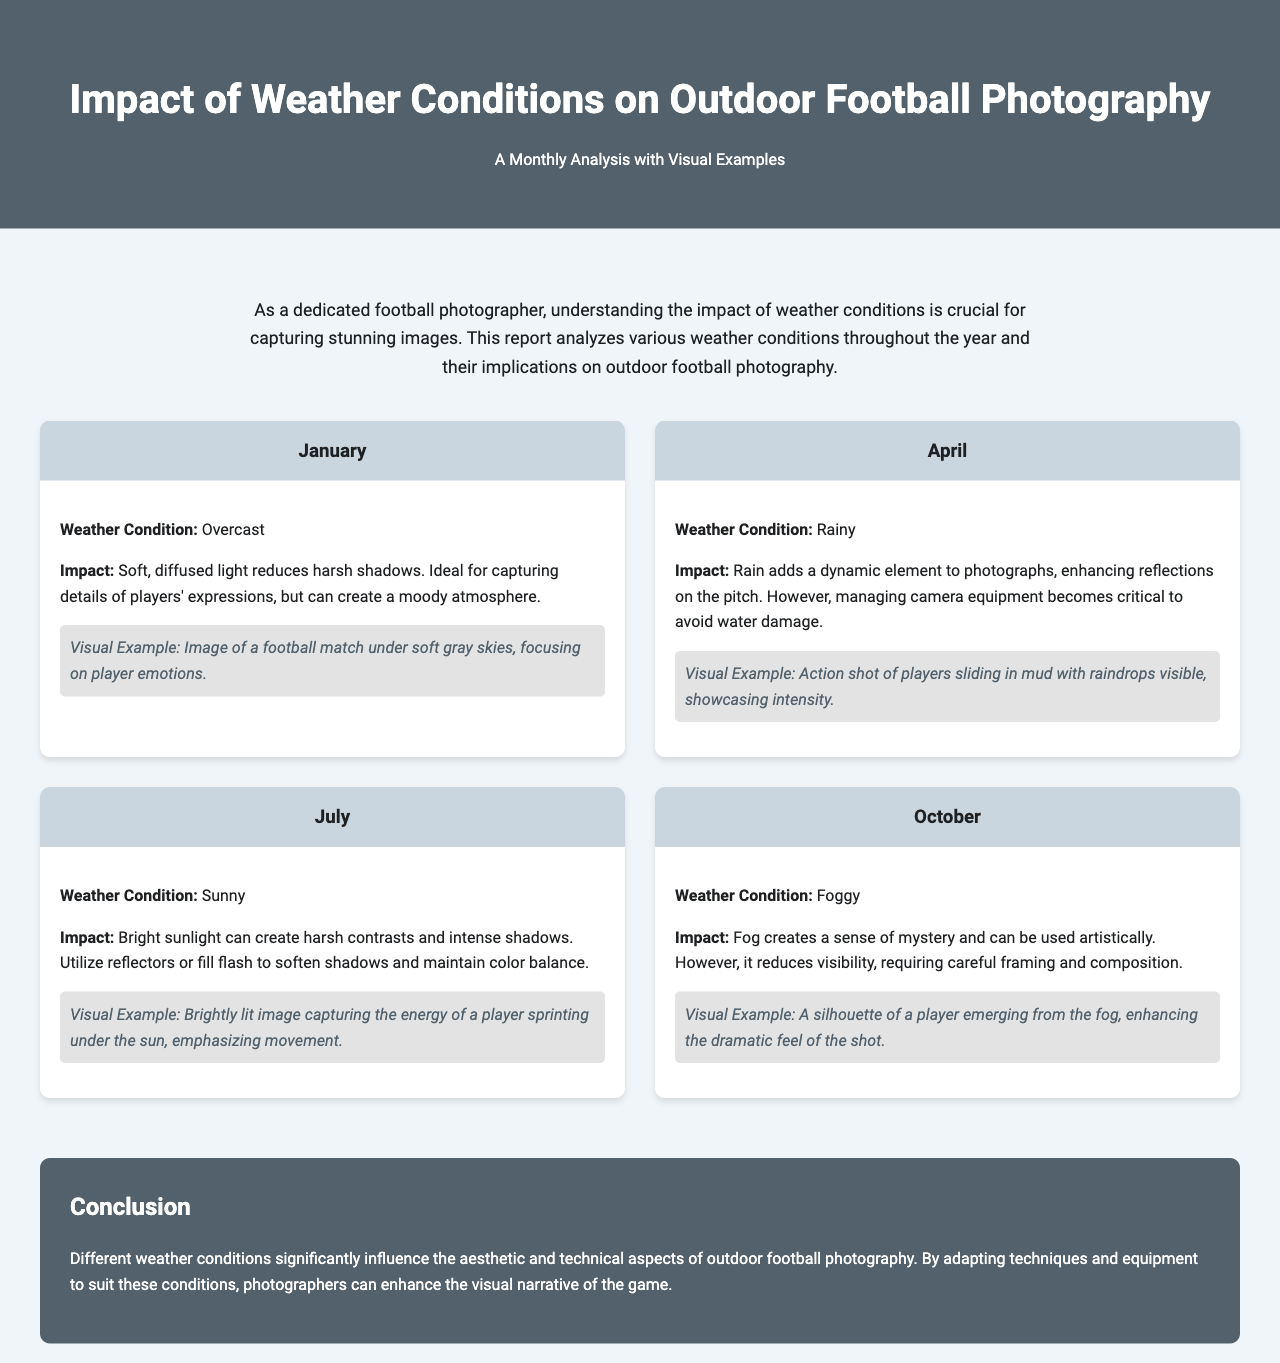What is the weather condition in April? The document specifies that in April, the weather condition is rainy.
Answer: Rainy What is the impact of sunny weather on photography? The document describes that bright sunlight can create harsh contrasts and intense shadows.
Answer: Harsh contrasts What visual example is provided for January? The document mentions an image focusing on player emotions under soft gray skies for January.
Answer: Image of a football match under soft gray skies What should photographers use to manage sunlight in July? The document suggests the use of reflectors or fill flash to soften shadows.
Answer: Reflectors or fill flash What is a key aspect of photography in foggy conditions? The document states that fog reduces visibility, requiring careful framing and composition.
Answer: Careful framing and composition How many months are analyzed in the report? The document features analysis for four months: January, April, July, and October.
Answer: Four months What is the overall conclusion regarding weather conditions? The document concludes that different weather conditions significantly influence outdoor football photography.
Answer: Significantly influence What can rain add to photographs, according to the report? The report indicates that rain adds a dynamic element to photographs.
Answer: Dynamic element 